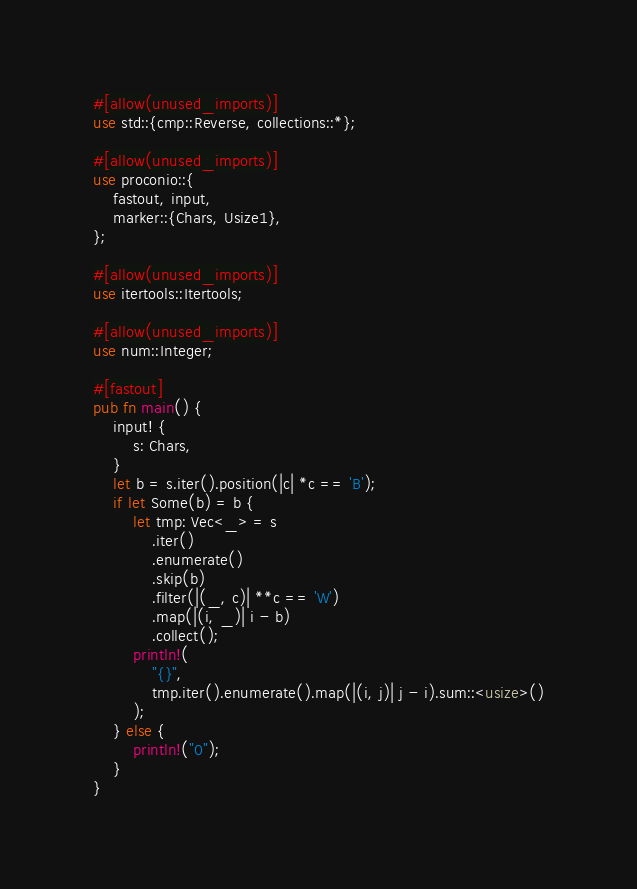Convert code to text. <code><loc_0><loc_0><loc_500><loc_500><_Rust_>#[allow(unused_imports)]
use std::{cmp::Reverse, collections::*};

#[allow(unused_imports)]
use proconio::{
    fastout, input,
    marker::{Chars, Usize1},
};

#[allow(unused_imports)]
use itertools::Itertools;

#[allow(unused_imports)]
use num::Integer;

#[fastout]
pub fn main() {
    input! {
        s: Chars,
    }
    let b = s.iter().position(|c| *c == 'B');
    if let Some(b) = b {
        let tmp: Vec<_> = s
            .iter()
            .enumerate()
            .skip(b)
            .filter(|(_, c)| **c == 'W')
            .map(|(i, _)| i - b)
            .collect();
        println!(
            "{}",
            tmp.iter().enumerate().map(|(i, j)| j - i).sum::<usize>()
        );
    } else {
        println!("0");
    }
}
</code> 